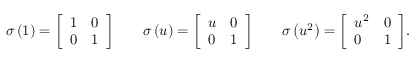Convert formula to latex. <formula><loc_0><loc_0><loc_500><loc_500>\sigma \left ( 1 \right ) = { \left [ \begin{array} { l l } { 1 } & { 0 } \\ { 0 } & { 1 } \end{array} \right ] } \quad \sigma \left ( u \right ) = { \left [ \begin{array} { l l } { u } & { 0 } \\ { 0 } & { 1 } \end{array} \right ] } \quad \sigma \left ( u ^ { 2 } \right ) = { \left [ \begin{array} { l l } { u ^ { 2 } } & { 0 } \\ { 0 } & { 1 } \end{array} \right ] } .</formula> 